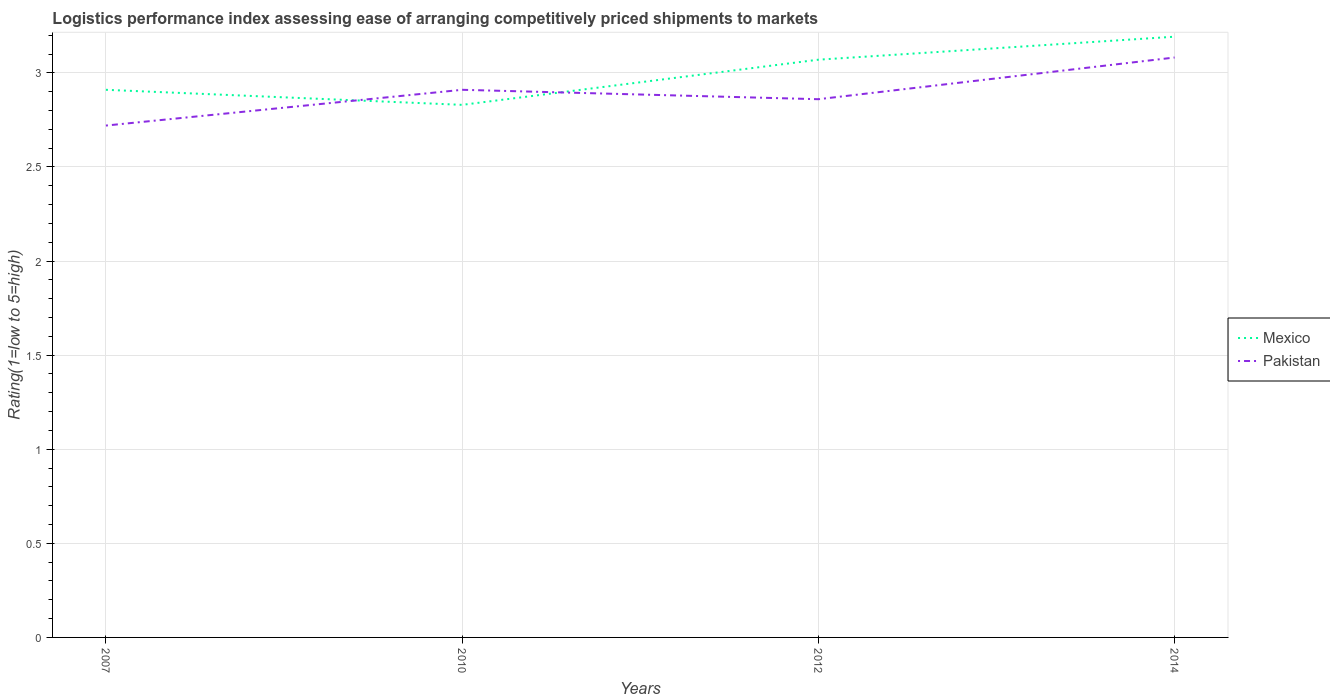Does the line corresponding to Mexico intersect with the line corresponding to Pakistan?
Ensure brevity in your answer.  Yes. Is the number of lines equal to the number of legend labels?
Provide a short and direct response. Yes. Across all years, what is the maximum Logistic performance index in Mexico?
Provide a succinct answer. 2.83. In which year was the Logistic performance index in Pakistan maximum?
Give a very brief answer. 2007. What is the total Logistic performance index in Mexico in the graph?
Your response must be concise. -0.16. What is the difference between the highest and the second highest Logistic performance index in Mexico?
Ensure brevity in your answer.  0.36. What is the difference between the highest and the lowest Logistic performance index in Pakistan?
Provide a succinct answer. 2. Is the Logistic performance index in Mexico strictly greater than the Logistic performance index in Pakistan over the years?
Offer a terse response. No. What is the difference between two consecutive major ticks on the Y-axis?
Provide a succinct answer. 0.5. Does the graph contain grids?
Provide a short and direct response. Yes. Where does the legend appear in the graph?
Keep it short and to the point. Center right. What is the title of the graph?
Keep it short and to the point. Logistics performance index assessing ease of arranging competitively priced shipments to markets. What is the label or title of the Y-axis?
Ensure brevity in your answer.  Rating(1=low to 5=high). What is the Rating(1=low to 5=high) of Mexico in 2007?
Offer a terse response. 2.91. What is the Rating(1=low to 5=high) of Pakistan in 2007?
Provide a short and direct response. 2.72. What is the Rating(1=low to 5=high) of Mexico in 2010?
Ensure brevity in your answer.  2.83. What is the Rating(1=low to 5=high) of Pakistan in 2010?
Your response must be concise. 2.91. What is the Rating(1=low to 5=high) of Mexico in 2012?
Offer a very short reply. 3.07. What is the Rating(1=low to 5=high) in Pakistan in 2012?
Make the answer very short. 2.86. What is the Rating(1=low to 5=high) in Mexico in 2014?
Offer a very short reply. 3.19. What is the Rating(1=low to 5=high) of Pakistan in 2014?
Provide a short and direct response. 3.08. Across all years, what is the maximum Rating(1=low to 5=high) in Mexico?
Offer a terse response. 3.19. Across all years, what is the maximum Rating(1=low to 5=high) of Pakistan?
Make the answer very short. 3.08. Across all years, what is the minimum Rating(1=low to 5=high) of Mexico?
Offer a very short reply. 2.83. Across all years, what is the minimum Rating(1=low to 5=high) of Pakistan?
Your answer should be very brief. 2.72. What is the total Rating(1=low to 5=high) of Mexico in the graph?
Give a very brief answer. 12. What is the total Rating(1=low to 5=high) in Pakistan in the graph?
Make the answer very short. 11.57. What is the difference between the Rating(1=low to 5=high) of Mexico in 2007 and that in 2010?
Provide a short and direct response. 0.08. What is the difference between the Rating(1=low to 5=high) in Pakistan in 2007 and that in 2010?
Give a very brief answer. -0.19. What is the difference between the Rating(1=low to 5=high) of Mexico in 2007 and that in 2012?
Provide a succinct answer. -0.16. What is the difference between the Rating(1=low to 5=high) in Pakistan in 2007 and that in 2012?
Offer a terse response. -0.14. What is the difference between the Rating(1=low to 5=high) of Mexico in 2007 and that in 2014?
Give a very brief answer. -0.28. What is the difference between the Rating(1=low to 5=high) in Pakistan in 2007 and that in 2014?
Give a very brief answer. -0.36. What is the difference between the Rating(1=low to 5=high) of Mexico in 2010 and that in 2012?
Keep it short and to the point. -0.24. What is the difference between the Rating(1=low to 5=high) in Pakistan in 2010 and that in 2012?
Make the answer very short. 0.05. What is the difference between the Rating(1=low to 5=high) in Mexico in 2010 and that in 2014?
Offer a terse response. -0.36. What is the difference between the Rating(1=low to 5=high) in Pakistan in 2010 and that in 2014?
Provide a succinct answer. -0.17. What is the difference between the Rating(1=low to 5=high) of Mexico in 2012 and that in 2014?
Ensure brevity in your answer.  -0.12. What is the difference between the Rating(1=low to 5=high) of Pakistan in 2012 and that in 2014?
Give a very brief answer. -0.22. What is the difference between the Rating(1=low to 5=high) of Mexico in 2007 and the Rating(1=low to 5=high) of Pakistan in 2014?
Provide a short and direct response. -0.17. What is the difference between the Rating(1=low to 5=high) of Mexico in 2010 and the Rating(1=low to 5=high) of Pakistan in 2012?
Keep it short and to the point. -0.03. What is the difference between the Rating(1=low to 5=high) in Mexico in 2010 and the Rating(1=low to 5=high) in Pakistan in 2014?
Provide a succinct answer. -0.25. What is the difference between the Rating(1=low to 5=high) in Mexico in 2012 and the Rating(1=low to 5=high) in Pakistan in 2014?
Provide a succinct answer. -0.01. What is the average Rating(1=low to 5=high) of Mexico per year?
Give a very brief answer. 3. What is the average Rating(1=low to 5=high) of Pakistan per year?
Keep it short and to the point. 2.89. In the year 2007, what is the difference between the Rating(1=low to 5=high) of Mexico and Rating(1=low to 5=high) of Pakistan?
Your answer should be compact. 0.19. In the year 2010, what is the difference between the Rating(1=low to 5=high) of Mexico and Rating(1=low to 5=high) of Pakistan?
Your answer should be very brief. -0.08. In the year 2012, what is the difference between the Rating(1=low to 5=high) of Mexico and Rating(1=low to 5=high) of Pakistan?
Your answer should be very brief. 0.21. In the year 2014, what is the difference between the Rating(1=low to 5=high) of Mexico and Rating(1=low to 5=high) of Pakistan?
Provide a succinct answer. 0.11. What is the ratio of the Rating(1=low to 5=high) in Mexico in 2007 to that in 2010?
Provide a short and direct response. 1.03. What is the ratio of the Rating(1=low to 5=high) in Pakistan in 2007 to that in 2010?
Offer a very short reply. 0.93. What is the ratio of the Rating(1=low to 5=high) of Mexico in 2007 to that in 2012?
Make the answer very short. 0.95. What is the ratio of the Rating(1=low to 5=high) in Pakistan in 2007 to that in 2012?
Offer a very short reply. 0.95. What is the ratio of the Rating(1=low to 5=high) of Mexico in 2007 to that in 2014?
Ensure brevity in your answer.  0.91. What is the ratio of the Rating(1=low to 5=high) in Pakistan in 2007 to that in 2014?
Provide a short and direct response. 0.88. What is the ratio of the Rating(1=low to 5=high) of Mexico in 2010 to that in 2012?
Ensure brevity in your answer.  0.92. What is the ratio of the Rating(1=low to 5=high) of Pakistan in 2010 to that in 2012?
Your response must be concise. 1.02. What is the ratio of the Rating(1=low to 5=high) of Mexico in 2010 to that in 2014?
Your answer should be very brief. 0.89. What is the ratio of the Rating(1=low to 5=high) in Pakistan in 2010 to that in 2014?
Ensure brevity in your answer.  0.94. What is the ratio of the Rating(1=low to 5=high) of Mexico in 2012 to that in 2014?
Provide a short and direct response. 0.96. What is the ratio of the Rating(1=low to 5=high) in Pakistan in 2012 to that in 2014?
Give a very brief answer. 0.93. What is the difference between the highest and the second highest Rating(1=low to 5=high) in Mexico?
Give a very brief answer. 0.12. What is the difference between the highest and the second highest Rating(1=low to 5=high) of Pakistan?
Provide a short and direct response. 0.17. What is the difference between the highest and the lowest Rating(1=low to 5=high) of Mexico?
Your answer should be compact. 0.36. What is the difference between the highest and the lowest Rating(1=low to 5=high) in Pakistan?
Ensure brevity in your answer.  0.36. 